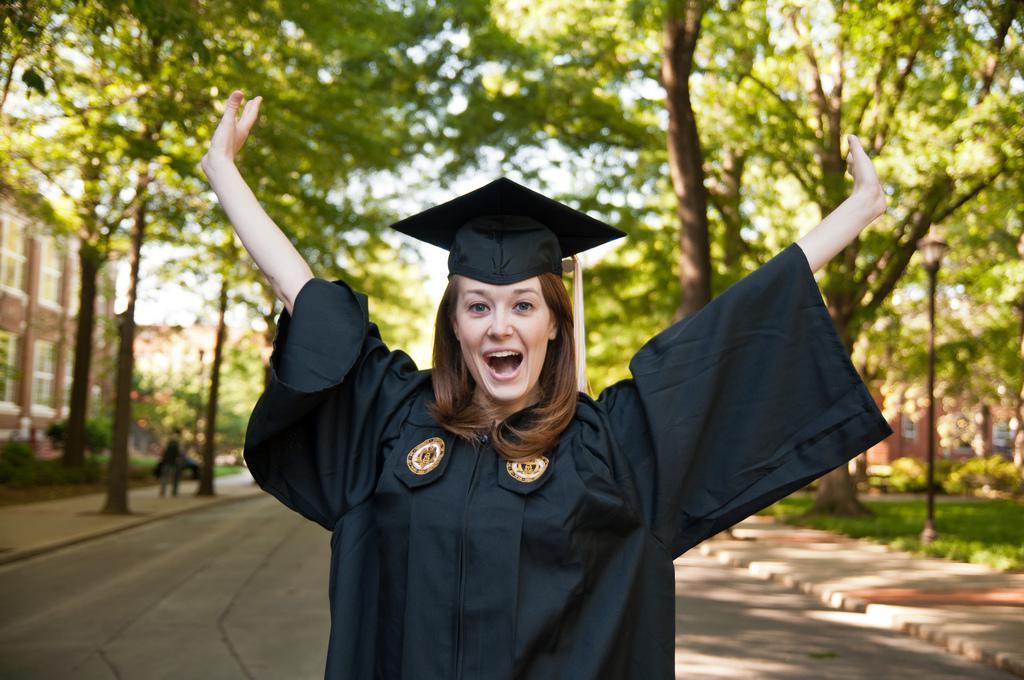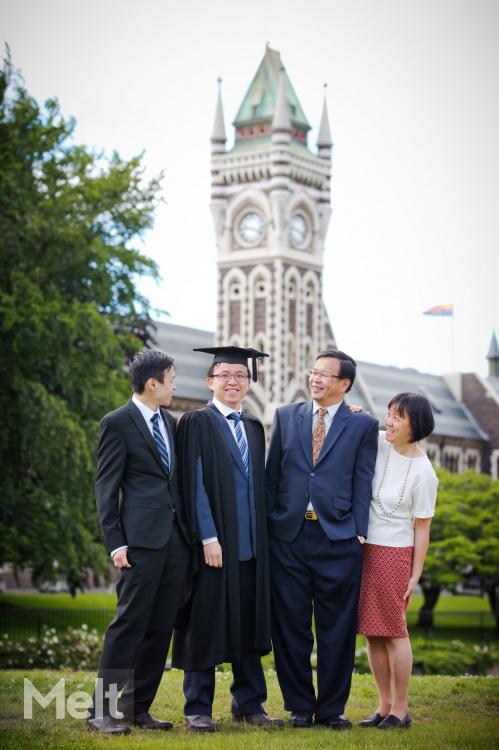The first image is the image on the left, the second image is the image on the right. For the images displayed, is the sentence "There are 3 people in one of the photos." factually correct? Answer yes or no. No. The first image is the image on the left, the second image is the image on the right. For the images displayed, is the sentence "There is a graduate with a flower necklace." factually correct? Answer yes or no. No. 